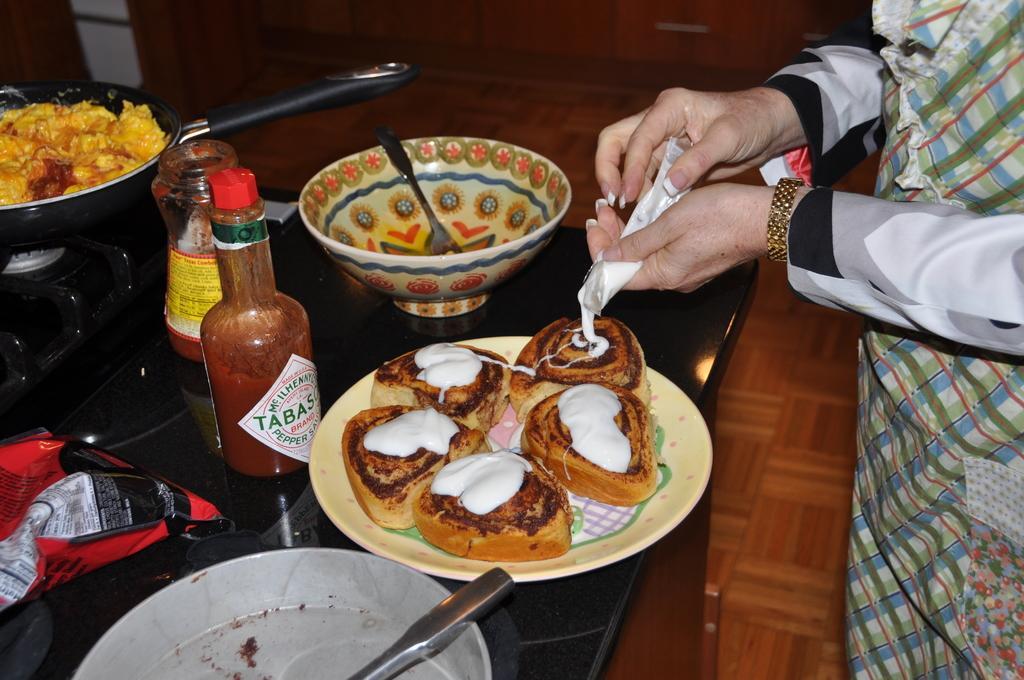In one or two sentences, can you explain what this image depicts? This image consists of a person pouring cream on the bread. The breads are kept in a plate. In the front, we can see the sauce bottle and a bowl along with a pan. At the bottom, there is a floor. 